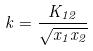<formula> <loc_0><loc_0><loc_500><loc_500>k = \frac { K _ { 1 2 } } { \sqrt { x _ { 1 } x _ { 2 } } }</formula> 